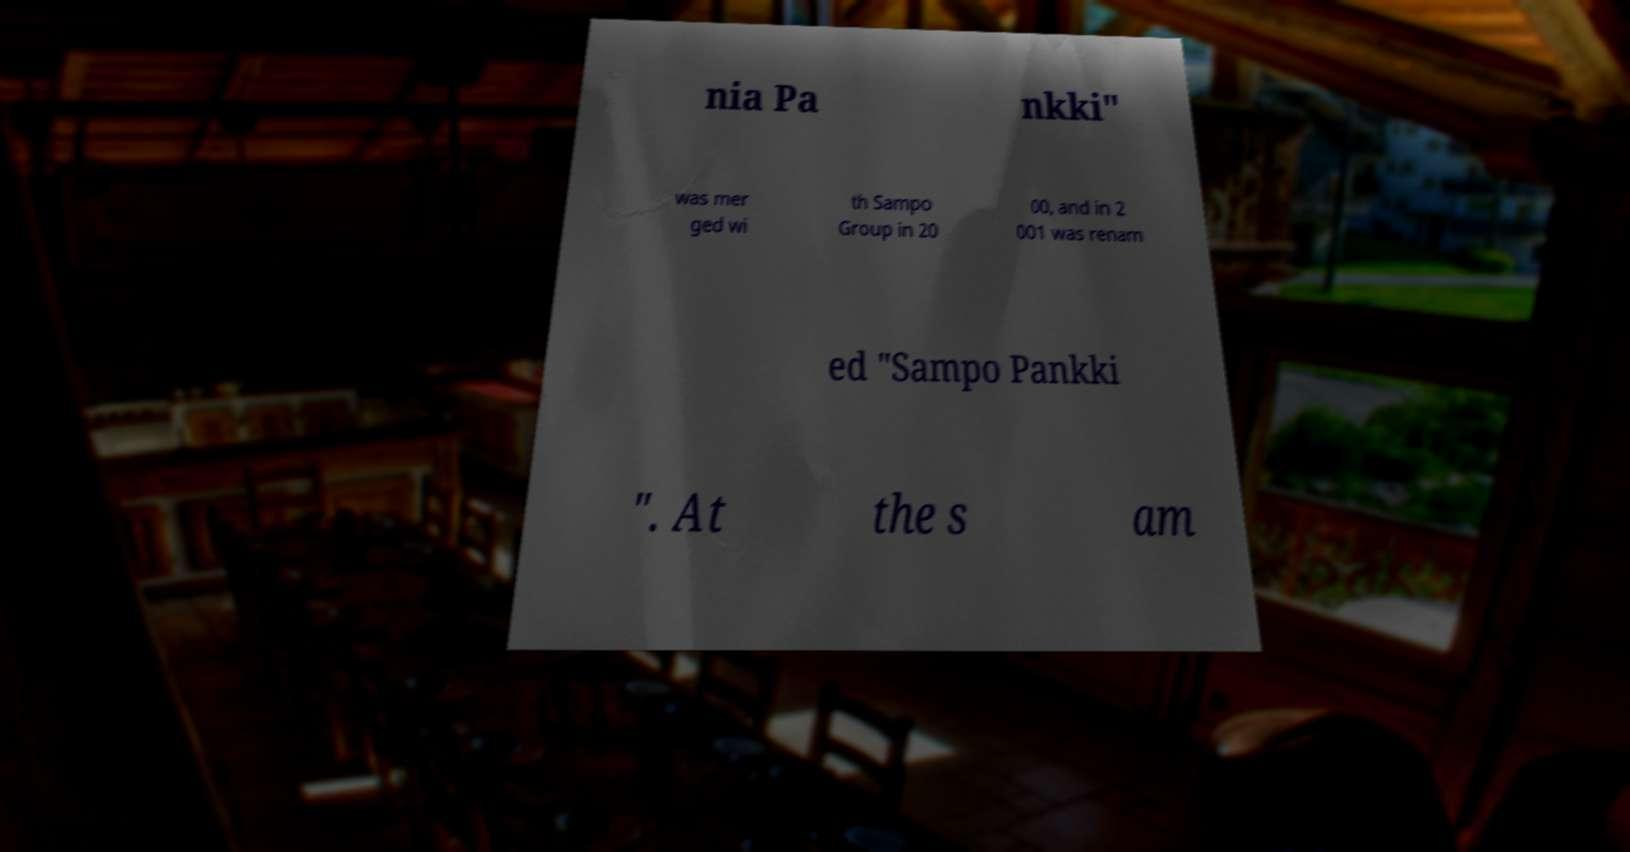Could you extract and type out the text from this image? nia Pa nkki" was mer ged wi th Sampo Group in 20 00, and in 2 001 was renam ed "Sampo Pankki ". At the s am 